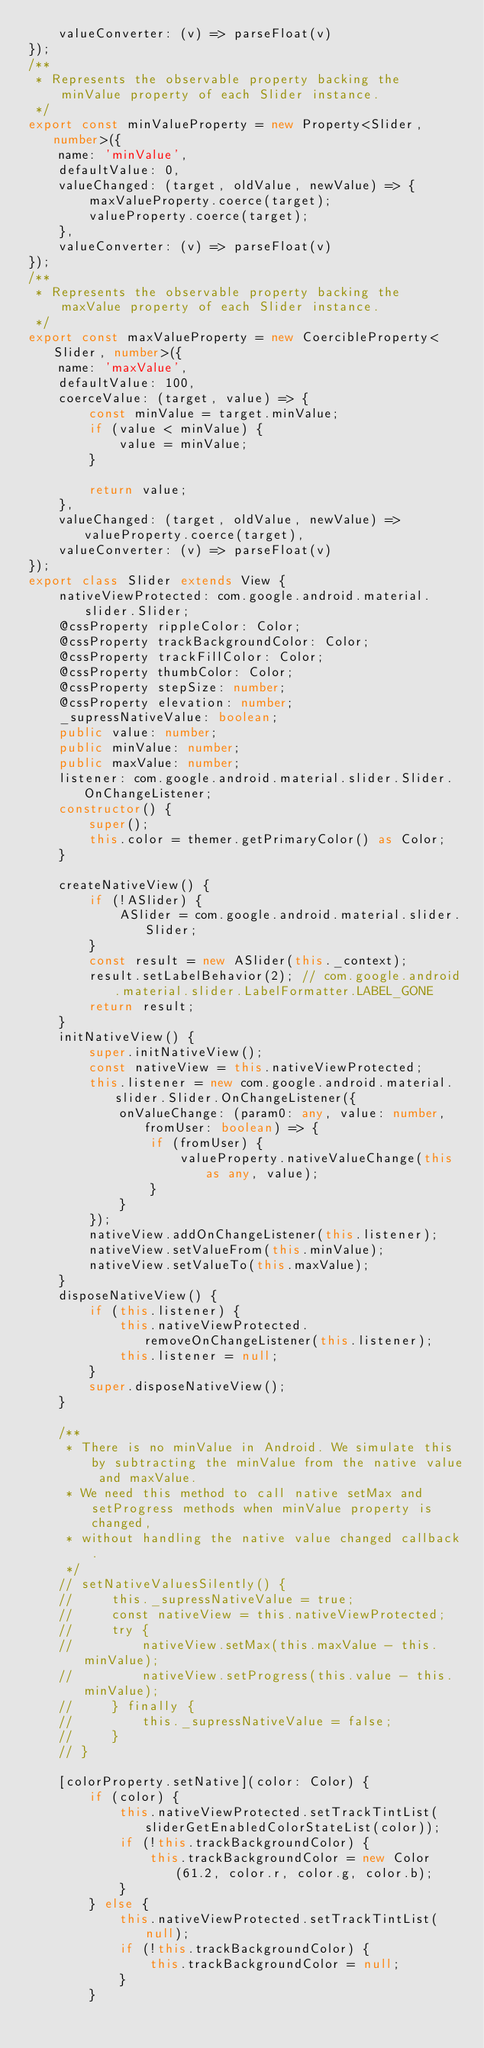<code> <loc_0><loc_0><loc_500><loc_500><_TypeScript_>    valueConverter: (v) => parseFloat(v)
});
/**
 * Represents the observable property backing the minValue property of each Slider instance.
 */
export const minValueProperty = new Property<Slider, number>({
    name: 'minValue',
    defaultValue: 0,
    valueChanged: (target, oldValue, newValue) => {
        maxValueProperty.coerce(target);
        valueProperty.coerce(target);
    },
    valueConverter: (v) => parseFloat(v)
});
/**
 * Represents the observable property backing the maxValue property of each Slider instance.
 */
export const maxValueProperty = new CoercibleProperty<Slider, number>({
    name: 'maxValue',
    defaultValue: 100,
    coerceValue: (target, value) => {
        const minValue = target.minValue;
        if (value < minValue) {
            value = minValue;
        }

        return value;
    },
    valueChanged: (target, oldValue, newValue) => valueProperty.coerce(target),
    valueConverter: (v) => parseFloat(v)
});
export class Slider extends View {
    nativeViewProtected: com.google.android.material.slider.Slider;
    @cssProperty rippleColor: Color;
    @cssProperty trackBackgroundColor: Color;
    @cssProperty trackFillColor: Color;
    @cssProperty thumbColor: Color;
    @cssProperty stepSize: number;
    @cssProperty elevation: number;
    _supressNativeValue: boolean;
    public value: number;
    public minValue: number;
    public maxValue: number;
    listener: com.google.android.material.slider.Slider.OnChangeListener;
    constructor() {
        super();
        this.color = themer.getPrimaryColor() as Color;
    }

    createNativeView() {
        if (!ASlider) {
            ASlider = com.google.android.material.slider.Slider;
        }
        const result = new ASlider(this._context);
        result.setLabelBehavior(2); // com.google.android.material.slider.LabelFormatter.LABEL_GONE
        return result;
    }
    initNativeView() {
        super.initNativeView();
        const nativeView = this.nativeViewProtected;
        this.listener = new com.google.android.material.slider.Slider.OnChangeListener({
            onValueChange: (param0: any, value: number, fromUser: boolean) => {
                if (fromUser) {
                    valueProperty.nativeValueChange(this as any, value);
                }
            }
        });
        nativeView.addOnChangeListener(this.listener);
        nativeView.setValueFrom(this.minValue);
        nativeView.setValueTo(this.maxValue);
    }
    disposeNativeView() {
        if (this.listener) {
            this.nativeViewProtected.removeOnChangeListener(this.listener);
            this.listener = null;
        }
        super.disposeNativeView();
    }

    /**
     * There is no minValue in Android. We simulate this by subtracting the minValue from the native value and maxValue.
     * We need this method to call native setMax and setProgress methods when minValue property is changed,
     * without handling the native value changed callback.
     */
    // setNativeValuesSilently() {
    //     this._supressNativeValue = true;
    //     const nativeView = this.nativeViewProtected;
    //     try {
    //         nativeView.setMax(this.maxValue - this.minValue);
    //         nativeView.setProgress(this.value - this.minValue);
    //     } finally {
    //         this._supressNativeValue = false;
    //     }
    // }

    [colorProperty.setNative](color: Color) {
        if (color) {
            this.nativeViewProtected.setTrackTintList(sliderGetEnabledColorStateList(color));
            if (!this.trackBackgroundColor) {
                this.trackBackgroundColor = new Color(61.2, color.r, color.g, color.b);
            }
        } else {
            this.nativeViewProtected.setTrackTintList(null);
            if (!this.trackBackgroundColor) {
                this.trackBackgroundColor = null;
            }
        }
</code> 